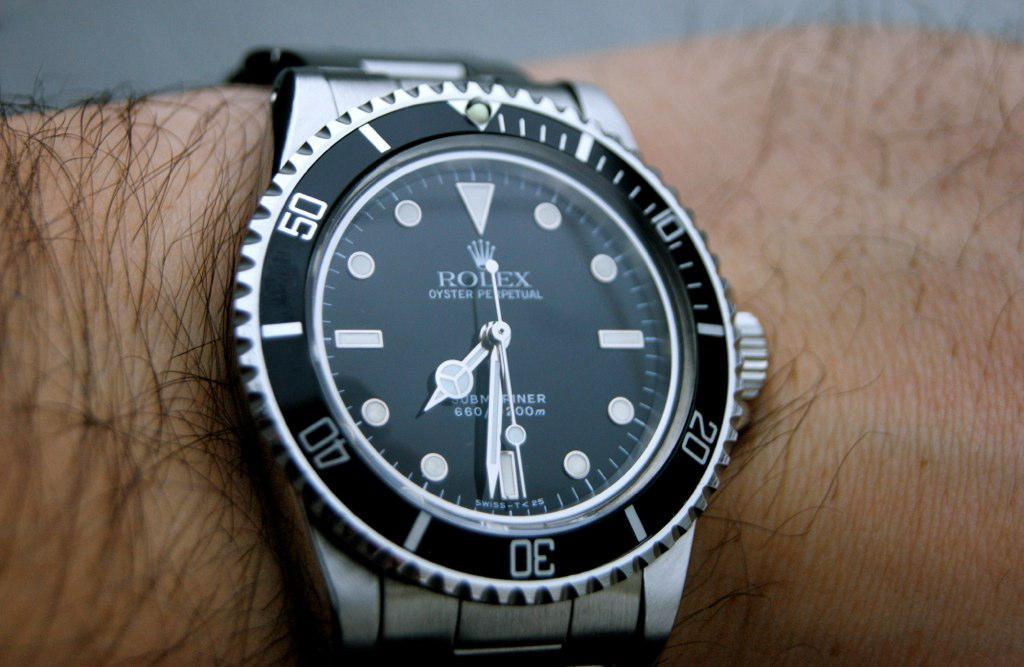<image>
Summarize the visual content of the image. A Rolex watch with a black face on a man's wrist. 